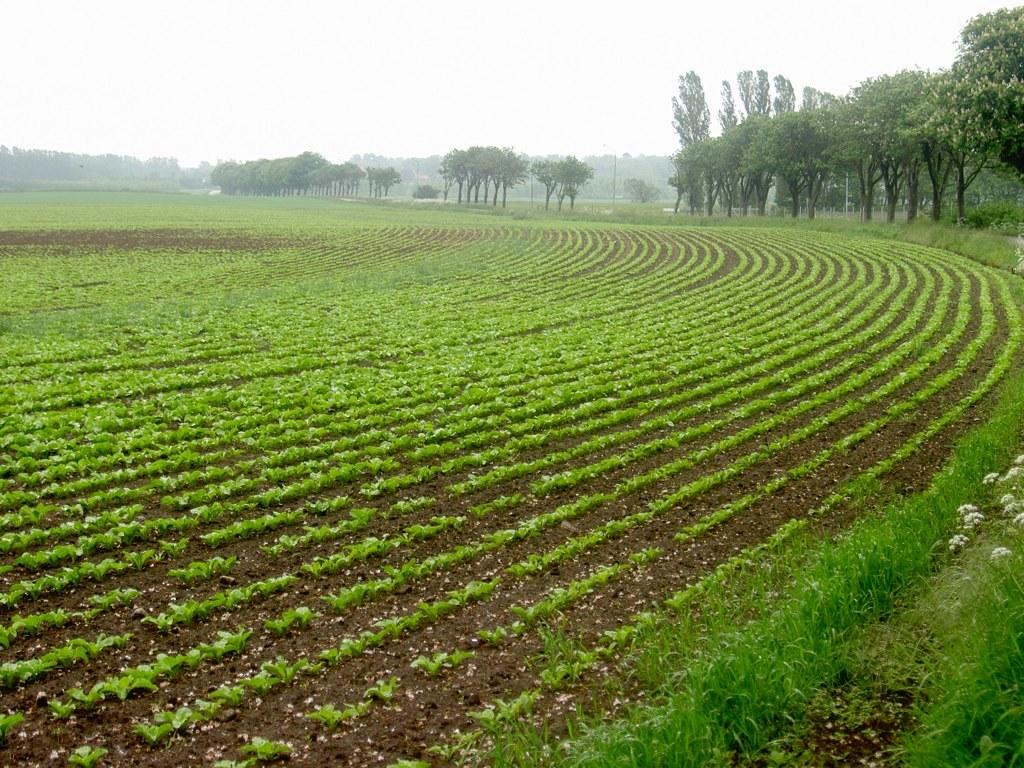What type of plants can be seen in the image? There is a crop with plant saplings in the image, as well as grass plants around the crop. Are there any other types of plants visible in the image? Yes, there are trees in the image. What can be seen in the background of the image? The background of the image includes trees and fog. What part of the natural environment is visible in the image? The sky is visible in the background of the image. What type of trousers are the trees wearing in the image? Trees do not wear trousers, as they are plants and not human beings. 